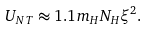Convert formula to latex. <formula><loc_0><loc_0><loc_500><loc_500>U _ { N T } \approx 1 . 1 m _ { H } N _ { H } \xi ^ { 2 } .</formula> 